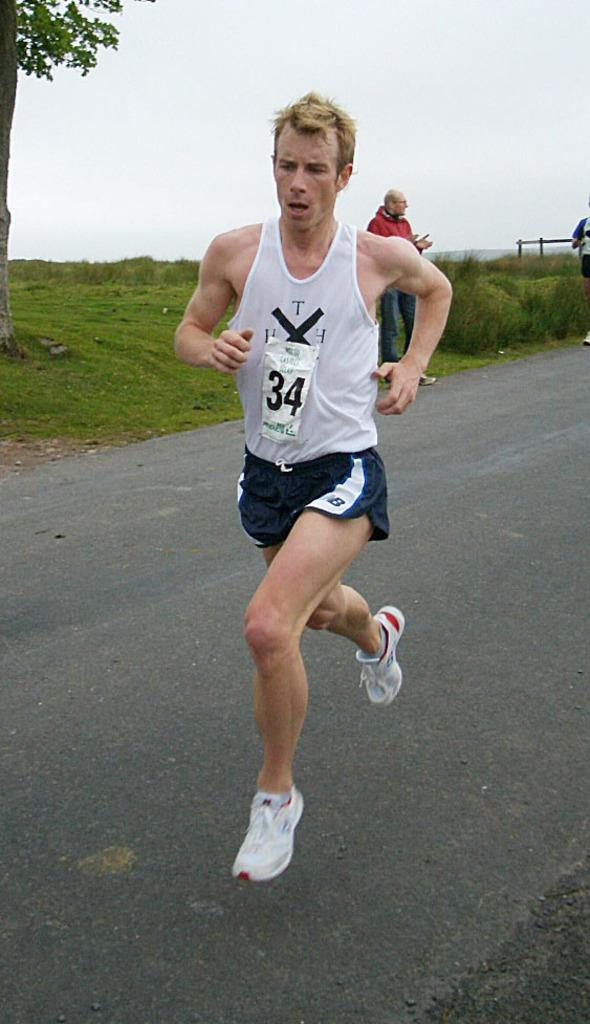Provide a one-sentence caption for the provided image. Runner #34 runs down the road in a pair of blue NB shorts. 